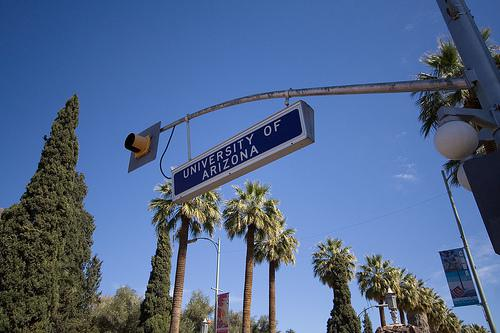Question: what is it?
Choices:
A. University Of Arizona street sign.
B. A street light.
C. A rubber ball.
D. A small dog.
Answer with the letter. Answer: A Question: where is this scene?
Choices:
A. Tucson Arizona.
B. In my back yard.
C. At the local park.
D. By the beach.
Answer with the letter. Answer: A Question: why is it there?
Choices:
A. It was the best place to put it.
B. To show the name of the street.
C. It's easy to see it.
D. Somebody moved it there.
Answer with the letter. Answer: B Question: when was it put up?
Choices:
A. When the street was made.
B. Two years ago.
C. In the spring.
D. Early in the morning.
Answer with the letter. Answer: A 